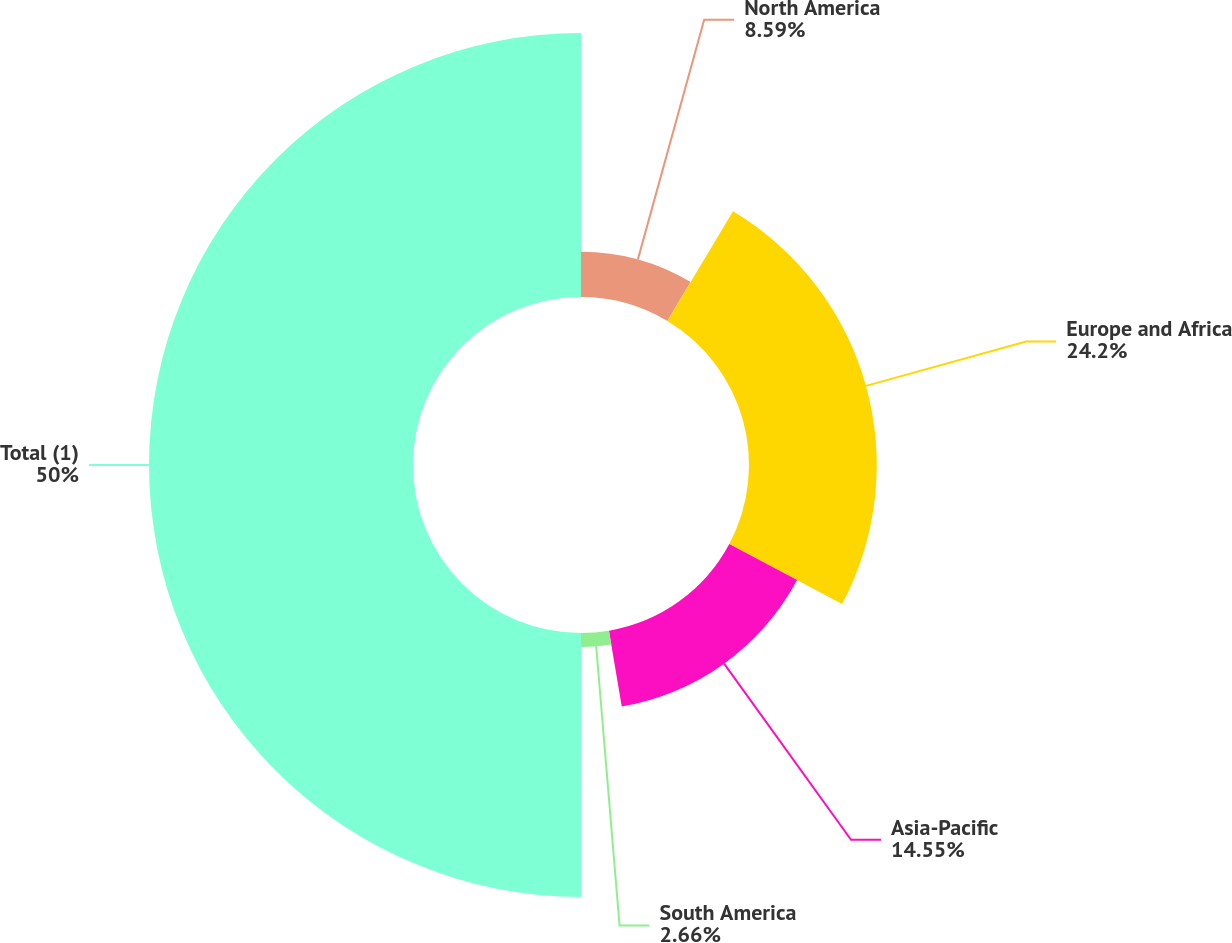Convert chart. <chart><loc_0><loc_0><loc_500><loc_500><pie_chart><fcel>North America<fcel>Europe and Africa<fcel>Asia-Pacific<fcel>South America<fcel>Total (1)<nl><fcel>8.59%<fcel>24.2%<fcel>14.55%<fcel>2.66%<fcel>50.0%<nl></chart> 